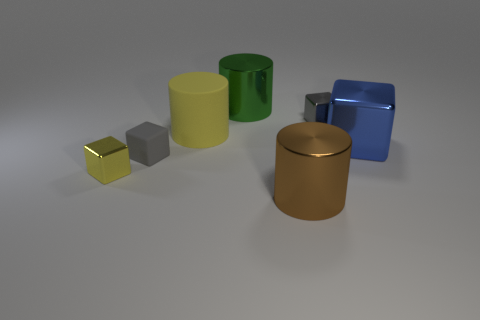There is a cylinder in front of the shiny thing that is on the right side of the gray thing behind the blue block; how big is it?
Ensure brevity in your answer.  Large. Do the tiny thing that is on the right side of the big green cylinder and the yellow object to the left of the big matte thing have the same shape?
Offer a terse response. Yes. What number of other things are there of the same color as the large rubber cylinder?
Ensure brevity in your answer.  1. There is a yellow object behind the yellow cube; is it the same size as the large brown metallic object?
Your answer should be very brief. Yes. Is the big thing in front of the yellow shiny block made of the same material as the tiny cube that is right of the brown metallic cylinder?
Keep it short and to the point. Yes. Is there another matte object that has the same size as the blue object?
Offer a terse response. Yes. What is the shape of the yellow object that is on the right side of the metal cube on the left side of the large metallic object behind the small gray metallic thing?
Offer a very short reply. Cylinder. Is the number of small blocks that are in front of the small gray rubber thing greater than the number of large blue metallic blocks?
Make the answer very short. No. Is there a yellow shiny thing that has the same shape as the large blue object?
Offer a terse response. Yes. Does the big brown object have the same material as the gray object that is on the left side of the large yellow cylinder?
Provide a succinct answer. No. 